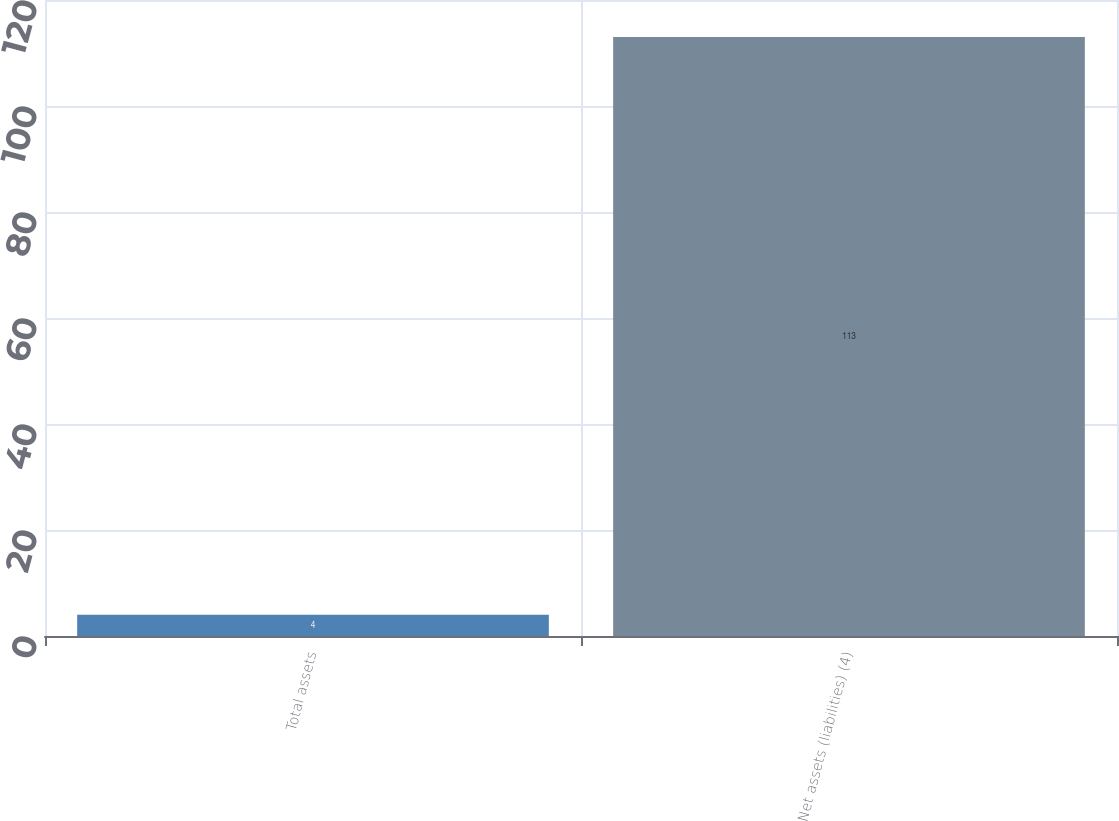<chart> <loc_0><loc_0><loc_500><loc_500><bar_chart><fcel>Total assets<fcel>Net assets (liabilities) (4)<nl><fcel>4<fcel>113<nl></chart> 